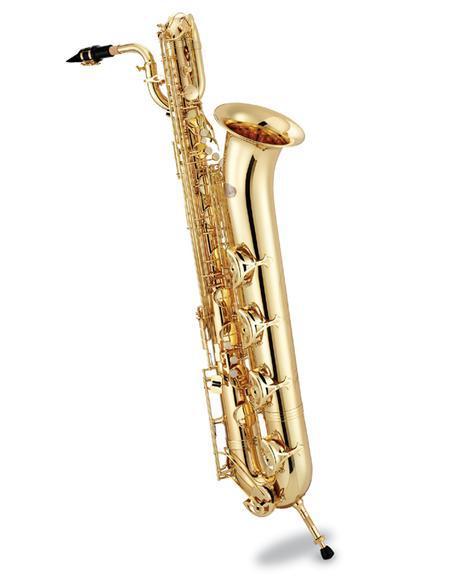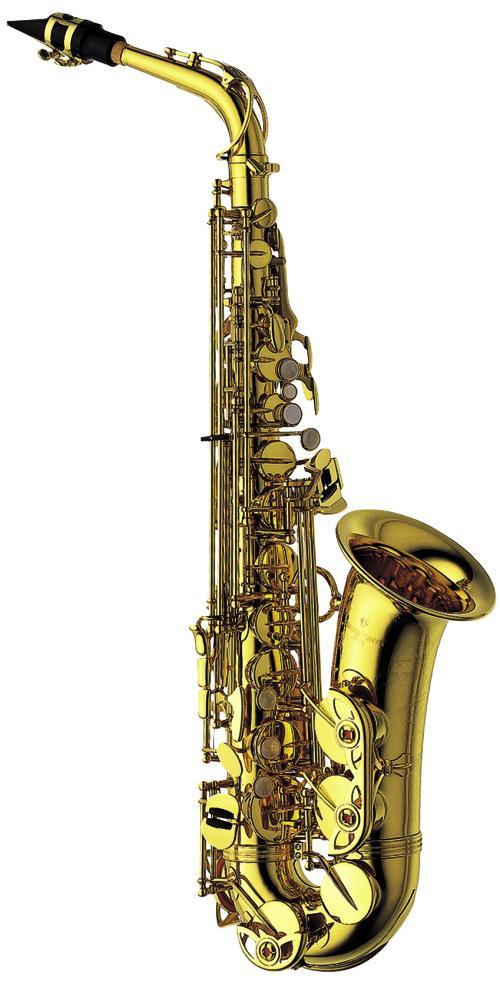The first image is the image on the left, the second image is the image on the right. Considering the images on both sides, is "Atleast one picture of a saxophone and no person visible." valid? Answer yes or no. Yes. The first image is the image on the left, the second image is the image on the right. Examine the images to the left and right. Is the description "The left image contains a human touching a saxophone." accurate? Answer yes or no. No. 